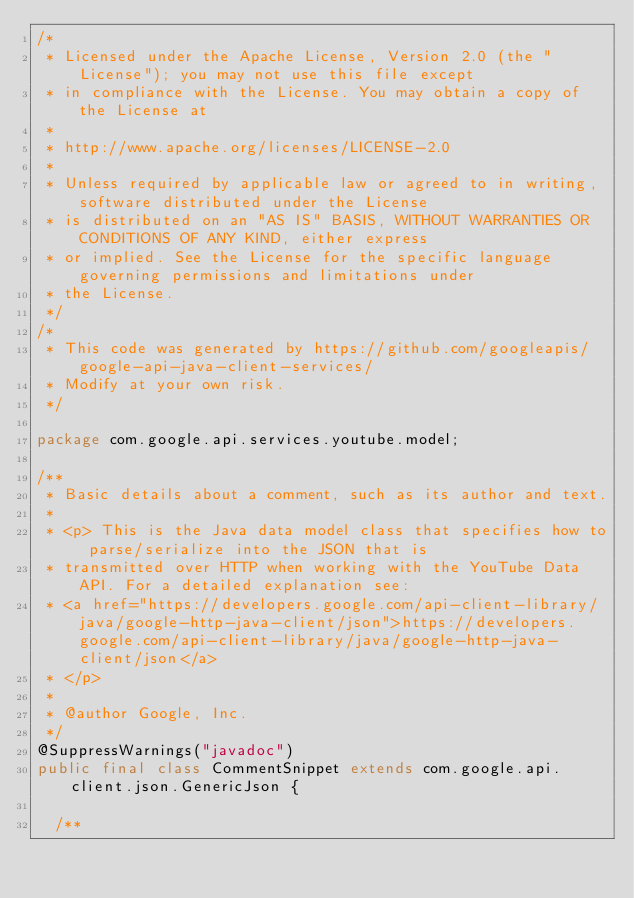<code> <loc_0><loc_0><loc_500><loc_500><_Java_>/*
 * Licensed under the Apache License, Version 2.0 (the "License"); you may not use this file except
 * in compliance with the License. You may obtain a copy of the License at
 *
 * http://www.apache.org/licenses/LICENSE-2.0
 *
 * Unless required by applicable law or agreed to in writing, software distributed under the License
 * is distributed on an "AS IS" BASIS, WITHOUT WARRANTIES OR CONDITIONS OF ANY KIND, either express
 * or implied. See the License for the specific language governing permissions and limitations under
 * the License.
 */
/*
 * This code was generated by https://github.com/googleapis/google-api-java-client-services/
 * Modify at your own risk.
 */

package com.google.api.services.youtube.model;

/**
 * Basic details about a comment, such as its author and text.
 *
 * <p> This is the Java data model class that specifies how to parse/serialize into the JSON that is
 * transmitted over HTTP when working with the YouTube Data API. For a detailed explanation see:
 * <a href="https://developers.google.com/api-client-library/java/google-http-java-client/json">https://developers.google.com/api-client-library/java/google-http-java-client/json</a>
 * </p>
 *
 * @author Google, Inc.
 */
@SuppressWarnings("javadoc")
public final class CommentSnippet extends com.google.api.client.json.GenericJson {

  /**</code> 